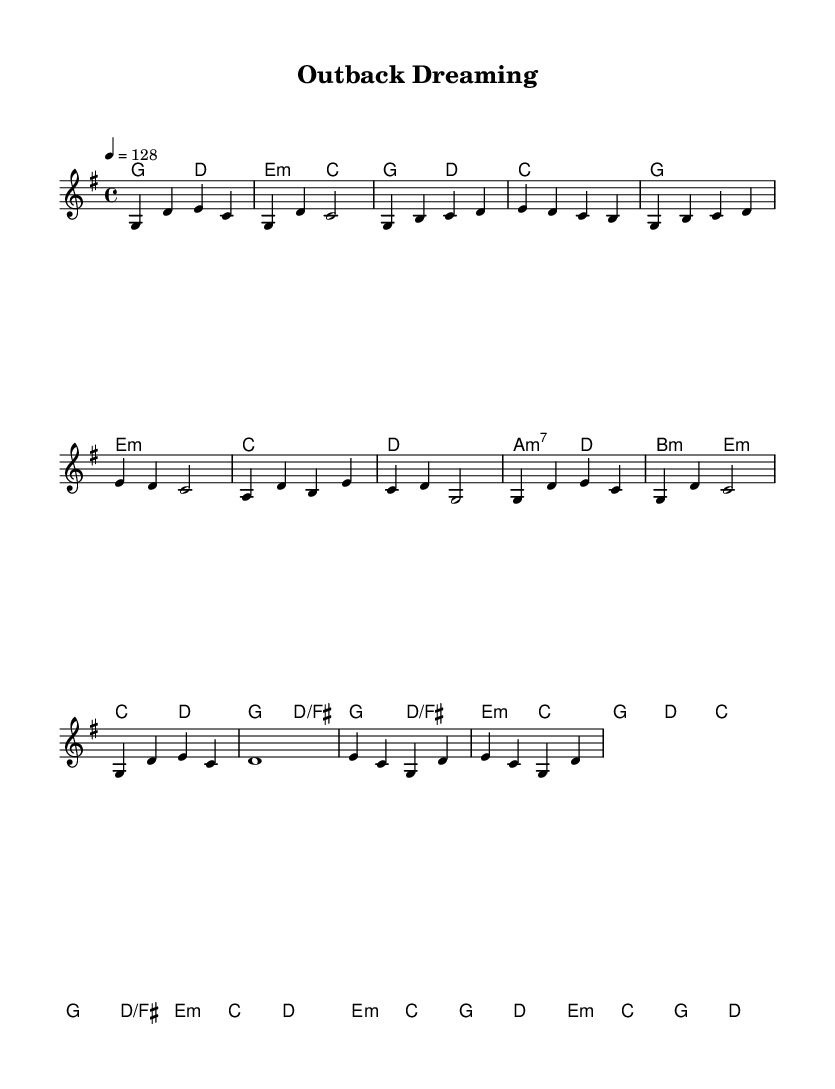What is the key signature of this music? The key signature is G major, which has one sharp (F#). This is indicated at the beginning of the sheet music, where the key signature is displayed.
Answer: G major What is the time signature of the piece? The time signature is 4/4, as shown at the beginning of the sheet music. This indicates that there are four beats in each measure and a quarter note receives one beat.
Answer: 4/4 What is the tempo of the music? The tempo is 128 beats per minute, indicated in the tempo marking above the staff. This defines the speed at which the piece should be played.
Answer: 128 How many measures are there in the chorus section? The chorus consists of 8 measures, which can be counted from the start of the chorus section to the end. Each line in the music corresponds to measures, and the chorus is distinctly organized in the score.
Answer: 8 Which chord appears most frequently in the verse? The chord that appears most frequently in the verse is E minor, which is indicated multiple times in the chord section for the verse. Analyzing the chord changes will show that E minor is the most common choice.
Answer: E minor In what section of the piece does the melody first reach a note higher than D? The melody first reaches a note higher than D in the pre-chorus section, where it reaches the note A. This is determined by reading the melodic line starting from the beginning and identifying the highest notes in each respective section.
Answer: Pre-Chorus What is the primary musical style indicated by the structure of this piece? The primary musical style indicated by the structure of this piece is K-Pop, which is characterized by a catchy melody, structured verses, a distinct chorus, and pre-chorus build-up sections typical in pop music. While the theme is inspired by Australian landscape paintings, the overall format aligns with K-Pop conventions.
Answer: K-Pop 